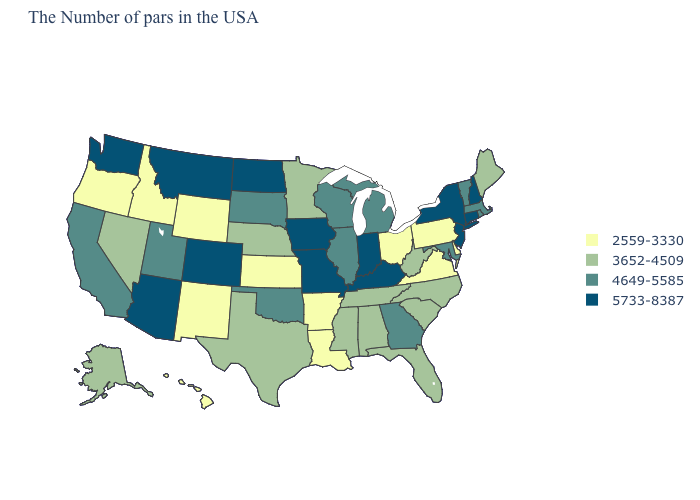Name the states that have a value in the range 4649-5585?
Short answer required. Massachusetts, Rhode Island, Vermont, Maryland, Georgia, Michigan, Wisconsin, Illinois, Oklahoma, South Dakota, Utah, California. What is the value of Oregon?
Answer briefly. 2559-3330. What is the value of New Hampshire?
Short answer required. 5733-8387. Name the states that have a value in the range 5733-8387?
Give a very brief answer. New Hampshire, Connecticut, New York, New Jersey, Kentucky, Indiana, Missouri, Iowa, North Dakota, Colorado, Montana, Arizona, Washington. Name the states that have a value in the range 2559-3330?
Keep it brief. Delaware, Pennsylvania, Virginia, Ohio, Louisiana, Arkansas, Kansas, Wyoming, New Mexico, Idaho, Oregon, Hawaii. Name the states that have a value in the range 3652-4509?
Short answer required. Maine, North Carolina, South Carolina, West Virginia, Florida, Alabama, Tennessee, Mississippi, Minnesota, Nebraska, Texas, Nevada, Alaska. Name the states that have a value in the range 4649-5585?
Quick response, please. Massachusetts, Rhode Island, Vermont, Maryland, Georgia, Michigan, Wisconsin, Illinois, Oklahoma, South Dakota, Utah, California. Does Montana have a lower value than Delaware?
Concise answer only. No. Name the states that have a value in the range 2559-3330?
Answer briefly. Delaware, Pennsylvania, Virginia, Ohio, Louisiana, Arkansas, Kansas, Wyoming, New Mexico, Idaho, Oregon, Hawaii. What is the lowest value in the West?
Write a very short answer. 2559-3330. Among the states that border Connecticut , does Massachusetts have the highest value?
Give a very brief answer. No. What is the value of Nevada?
Short answer required. 3652-4509. Name the states that have a value in the range 2559-3330?
Be succinct. Delaware, Pennsylvania, Virginia, Ohio, Louisiana, Arkansas, Kansas, Wyoming, New Mexico, Idaho, Oregon, Hawaii. What is the value of Connecticut?
Give a very brief answer. 5733-8387. 